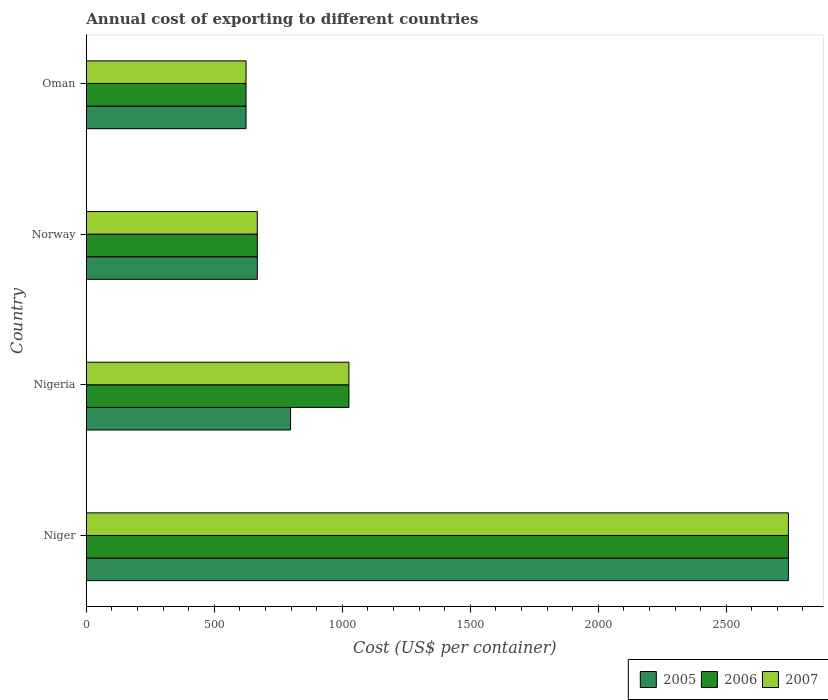How many different coloured bars are there?
Provide a succinct answer. 3. Are the number of bars on each tick of the Y-axis equal?
Offer a very short reply. Yes. How many bars are there on the 3rd tick from the top?
Your response must be concise. 3. How many bars are there on the 2nd tick from the bottom?
Your response must be concise. 3. What is the label of the 2nd group of bars from the top?
Make the answer very short. Norway. In how many cases, is the number of bars for a given country not equal to the number of legend labels?
Give a very brief answer. 0. What is the total annual cost of exporting in 2007 in Norway?
Your answer should be compact. 668. Across all countries, what is the maximum total annual cost of exporting in 2005?
Keep it short and to the point. 2743. Across all countries, what is the minimum total annual cost of exporting in 2006?
Your answer should be very brief. 624. In which country was the total annual cost of exporting in 2007 maximum?
Offer a very short reply. Niger. In which country was the total annual cost of exporting in 2005 minimum?
Give a very brief answer. Oman. What is the total total annual cost of exporting in 2005 in the graph?
Offer a terse response. 4833. What is the difference between the total annual cost of exporting in 2006 in Nigeria and that in Norway?
Your answer should be compact. 358. What is the difference between the total annual cost of exporting in 2006 in Niger and the total annual cost of exporting in 2007 in Oman?
Offer a terse response. 2119. What is the average total annual cost of exporting in 2007 per country?
Offer a very short reply. 1265.25. What is the difference between the total annual cost of exporting in 2005 and total annual cost of exporting in 2007 in Nigeria?
Your response must be concise. -228. What is the ratio of the total annual cost of exporting in 2007 in Niger to that in Norway?
Your answer should be very brief. 4.11. Is the total annual cost of exporting in 2007 in Niger less than that in Norway?
Your response must be concise. No. Is the difference between the total annual cost of exporting in 2005 in Nigeria and Oman greater than the difference between the total annual cost of exporting in 2007 in Nigeria and Oman?
Ensure brevity in your answer.  No. What is the difference between the highest and the second highest total annual cost of exporting in 2007?
Ensure brevity in your answer.  1717. What is the difference between the highest and the lowest total annual cost of exporting in 2007?
Offer a very short reply. 2119. In how many countries, is the total annual cost of exporting in 2005 greater than the average total annual cost of exporting in 2005 taken over all countries?
Your answer should be compact. 1. Is the sum of the total annual cost of exporting in 2007 in Niger and Oman greater than the maximum total annual cost of exporting in 2005 across all countries?
Ensure brevity in your answer.  Yes. What does the 2nd bar from the bottom in Norway represents?
Your response must be concise. 2006. Are all the bars in the graph horizontal?
Your response must be concise. Yes. What is the difference between two consecutive major ticks on the X-axis?
Make the answer very short. 500. Does the graph contain any zero values?
Your response must be concise. No. Does the graph contain grids?
Ensure brevity in your answer.  No. Where does the legend appear in the graph?
Offer a terse response. Bottom right. How many legend labels are there?
Ensure brevity in your answer.  3. How are the legend labels stacked?
Provide a succinct answer. Horizontal. What is the title of the graph?
Offer a very short reply. Annual cost of exporting to different countries. What is the label or title of the X-axis?
Offer a very short reply. Cost (US$ per container). What is the label or title of the Y-axis?
Your answer should be compact. Country. What is the Cost (US$ per container) in 2005 in Niger?
Offer a terse response. 2743. What is the Cost (US$ per container) in 2006 in Niger?
Offer a terse response. 2743. What is the Cost (US$ per container) in 2007 in Niger?
Make the answer very short. 2743. What is the Cost (US$ per container) of 2005 in Nigeria?
Your answer should be very brief. 798. What is the Cost (US$ per container) of 2006 in Nigeria?
Your response must be concise. 1026. What is the Cost (US$ per container) in 2007 in Nigeria?
Your response must be concise. 1026. What is the Cost (US$ per container) of 2005 in Norway?
Offer a terse response. 668. What is the Cost (US$ per container) of 2006 in Norway?
Make the answer very short. 668. What is the Cost (US$ per container) in 2007 in Norway?
Ensure brevity in your answer.  668. What is the Cost (US$ per container) in 2005 in Oman?
Your answer should be very brief. 624. What is the Cost (US$ per container) in 2006 in Oman?
Your answer should be very brief. 624. What is the Cost (US$ per container) in 2007 in Oman?
Offer a very short reply. 624. Across all countries, what is the maximum Cost (US$ per container) of 2005?
Keep it short and to the point. 2743. Across all countries, what is the maximum Cost (US$ per container) of 2006?
Provide a succinct answer. 2743. Across all countries, what is the maximum Cost (US$ per container) of 2007?
Your answer should be compact. 2743. Across all countries, what is the minimum Cost (US$ per container) of 2005?
Offer a very short reply. 624. Across all countries, what is the minimum Cost (US$ per container) in 2006?
Offer a very short reply. 624. Across all countries, what is the minimum Cost (US$ per container) in 2007?
Your answer should be very brief. 624. What is the total Cost (US$ per container) in 2005 in the graph?
Provide a short and direct response. 4833. What is the total Cost (US$ per container) of 2006 in the graph?
Offer a very short reply. 5061. What is the total Cost (US$ per container) in 2007 in the graph?
Give a very brief answer. 5061. What is the difference between the Cost (US$ per container) in 2005 in Niger and that in Nigeria?
Offer a very short reply. 1945. What is the difference between the Cost (US$ per container) of 2006 in Niger and that in Nigeria?
Your answer should be very brief. 1717. What is the difference between the Cost (US$ per container) of 2007 in Niger and that in Nigeria?
Your answer should be very brief. 1717. What is the difference between the Cost (US$ per container) of 2005 in Niger and that in Norway?
Provide a succinct answer. 2075. What is the difference between the Cost (US$ per container) of 2006 in Niger and that in Norway?
Your answer should be very brief. 2075. What is the difference between the Cost (US$ per container) in 2007 in Niger and that in Norway?
Offer a terse response. 2075. What is the difference between the Cost (US$ per container) of 2005 in Niger and that in Oman?
Provide a succinct answer. 2119. What is the difference between the Cost (US$ per container) in 2006 in Niger and that in Oman?
Provide a short and direct response. 2119. What is the difference between the Cost (US$ per container) in 2007 in Niger and that in Oman?
Give a very brief answer. 2119. What is the difference between the Cost (US$ per container) in 2005 in Nigeria and that in Norway?
Give a very brief answer. 130. What is the difference between the Cost (US$ per container) in 2006 in Nigeria and that in Norway?
Offer a terse response. 358. What is the difference between the Cost (US$ per container) in 2007 in Nigeria and that in Norway?
Ensure brevity in your answer.  358. What is the difference between the Cost (US$ per container) of 2005 in Nigeria and that in Oman?
Keep it short and to the point. 174. What is the difference between the Cost (US$ per container) in 2006 in Nigeria and that in Oman?
Offer a very short reply. 402. What is the difference between the Cost (US$ per container) of 2007 in Nigeria and that in Oman?
Your response must be concise. 402. What is the difference between the Cost (US$ per container) in 2006 in Norway and that in Oman?
Your response must be concise. 44. What is the difference between the Cost (US$ per container) of 2007 in Norway and that in Oman?
Your response must be concise. 44. What is the difference between the Cost (US$ per container) in 2005 in Niger and the Cost (US$ per container) in 2006 in Nigeria?
Offer a terse response. 1717. What is the difference between the Cost (US$ per container) in 2005 in Niger and the Cost (US$ per container) in 2007 in Nigeria?
Make the answer very short. 1717. What is the difference between the Cost (US$ per container) of 2006 in Niger and the Cost (US$ per container) of 2007 in Nigeria?
Give a very brief answer. 1717. What is the difference between the Cost (US$ per container) of 2005 in Niger and the Cost (US$ per container) of 2006 in Norway?
Offer a terse response. 2075. What is the difference between the Cost (US$ per container) of 2005 in Niger and the Cost (US$ per container) of 2007 in Norway?
Your response must be concise. 2075. What is the difference between the Cost (US$ per container) in 2006 in Niger and the Cost (US$ per container) in 2007 in Norway?
Make the answer very short. 2075. What is the difference between the Cost (US$ per container) of 2005 in Niger and the Cost (US$ per container) of 2006 in Oman?
Provide a short and direct response. 2119. What is the difference between the Cost (US$ per container) of 2005 in Niger and the Cost (US$ per container) of 2007 in Oman?
Provide a succinct answer. 2119. What is the difference between the Cost (US$ per container) of 2006 in Niger and the Cost (US$ per container) of 2007 in Oman?
Give a very brief answer. 2119. What is the difference between the Cost (US$ per container) of 2005 in Nigeria and the Cost (US$ per container) of 2006 in Norway?
Your answer should be compact. 130. What is the difference between the Cost (US$ per container) of 2005 in Nigeria and the Cost (US$ per container) of 2007 in Norway?
Ensure brevity in your answer.  130. What is the difference between the Cost (US$ per container) of 2006 in Nigeria and the Cost (US$ per container) of 2007 in Norway?
Your response must be concise. 358. What is the difference between the Cost (US$ per container) in 2005 in Nigeria and the Cost (US$ per container) in 2006 in Oman?
Your answer should be very brief. 174. What is the difference between the Cost (US$ per container) in 2005 in Nigeria and the Cost (US$ per container) in 2007 in Oman?
Make the answer very short. 174. What is the difference between the Cost (US$ per container) of 2006 in Nigeria and the Cost (US$ per container) of 2007 in Oman?
Keep it short and to the point. 402. What is the difference between the Cost (US$ per container) of 2005 in Norway and the Cost (US$ per container) of 2007 in Oman?
Your response must be concise. 44. What is the average Cost (US$ per container) in 2005 per country?
Provide a succinct answer. 1208.25. What is the average Cost (US$ per container) in 2006 per country?
Give a very brief answer. 1265.25. What is the average Cost (US$ per container) of 2007 per country?
Give a very brief answer. 1265.25. What is the difference between the Cost (US$ per container) of 2005 and Cost (US$ per container) of 2006 in Niger?
Your response must be concise. 0. What is the difference between the Cost (US$ per container) in 2005 and Cost (US$ per container) in 2006 in Nigeria?
Keep it short and to the point. -228. What is the difference between the Cost (US$ per container) in 2005 and Cost (US$ per container) in 2007 in Nigeria?
Give a very brief answer. -228. What is the difference between the Cost (US$ per container) in 2005 and Cost (US$ per container) in 2006 in Norway?
Provide a succinct answer. 0. What is the difference between the Cost (US$ per container) of 2005 and Cost (US$ per container) of 2007 in Norway?
Your answer should be very brief. 0. What is the difference between the Cost (US$ per container) of 2006 and Cost (US$ per container) of 2007 in Norway?
Provide a short and direct response. 0. What is the difference between the Cost (US$ per container) in 2005 and Cost (US$ per container) in 2006 in Oman?
Offer a terse response. 0. What is the ratio of the Cost (US$ per container) in 2005 in Niger to that in Nigeria?
Offer a very short reply. 3.44. What is the ratio of the Cost (US$ per container) in 2006 in Niger to that in Nigeria?
Your answer should be very brief. 2.67. What is the ratio of the Cost (US$ per container) of 2007 in Niger to that in Nigeria?
Your answer should be compact. 2.67. What is the ratio of the Cost (US$ per container) in 2005 in Niger to that in Norway?
Keep it short and to the point. 4.11. What is the ratio of the Cost (US$ per container) in 2006 in Niger to that in Norway?
Keep it short and to the point. 4.11. What is the ratio of the Cost (US$ per container) of 2007 in Niger to that in Norway?
Provide a short and direct response. 4.11. What is the ratio of the Cost (US$ per container) of 2005 in Niger to that in Oman?
Your answer should be compact. 4.4. What is the ratio of the Cost (US$ per container) in 2006 in Niger to that in Oman?
Give a very brief answer. 4.4. What is the ratio of the Cost (US$ per container) of 2007 in Niger to that in Oman?
Your answer should be compact. 4.4. What is the ratio of the Cost (US$ per container) in 2005 in Nigeria to that in Norway?
Offer a terse response. 1.19. What is the ratio of the Cost (US$ per container) of 2006 in Nigeria to that in Norway?
Your response must be concise. 1.54. What is the ratio of the Cost (US$ per container) in 2007 in Nigeria to that in Norway?
Make the answer very short. 1.54. What is the ratio of the Cost (US$ per container) in 2005 in Nigeria to that in Oman?
Your answer should be very brief. 1.28. What is the ratio of the Cost (US$ per container) of 2006 in Nigeria to that in Oman?
Offer a very short reply. 1.64. What is the ratio of the Cost (US$ per container) of 2007 in Nigeria to that in Oman?
Give a very brief answer. 1.64. What is the ratio of the Cost (US$ per container) in 2005 in Norway to that in Oman?
Your answer should be compact. 1.07. What is the ratio of the Cost (US$ per container) of 2006 in Norway to that in Oman?
Provide a succinct answer. 1.07. What is the ratio of the Cost (US$ per container) in 2007 in Norway to that in Oman?
Keep it short and to the point. 1.07. What is the difference between the highest and the second highest Cost (US$ per container) of 2005?
Your response must be concise. 1945. What is the difference between the highest and the second highest Cost (US$ per container) of 2006?
Provide a succinct answer. 1717. What is the difference between the highest and the second highest Cost (US$ per container) of 2007?
Offer a terse response. 1717. What is the difference between the highest and the lowest Cost (US$ per container) in 2005?
Give a very brief answer. 2119. What is the difference between the highest and the lowest Cost (US$ per container) of 2006?
Keep it short and to the point. 2119. What is the difference between the highest and the lowest Cost (US$ per container) of 2007?
Offer a terse response. 2119. 